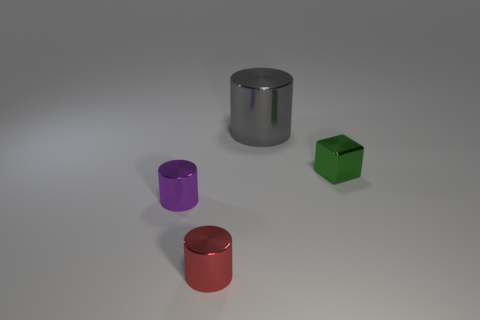The tiny cube that is the same material as the purple object is what color?
Offer a very short reply. Green. What number of objects are either large green balls or small green blocks?
Offer a terse response. 1. The green metallic object that is the same size as the red metallic object is what shape?
Make the answer very short. Cube. What number of cylinders are both in front of the purple object and behind the small shiny block?
Offer a terse response. 0. What is the cylinder that is in front of the purple cylinder made of?
Your answer should be very brief. Metal. There is a gray cylinder that is made of the same material as the tiny block; what size is it?
Offer a terse response. Large. Is the size of the object to the left of the red cylinder the same as the shiny cylinder in front of the tiny purple metal thing?
Ensure brevity in your answer.  Yes. There is a green object that is the same size as the purple metal cylinder; what is it made of?
Make the answer very short. Metal. The object that is behind the tiny purple object and to the left of the tiny green cube is made of what material?
Provide a succinct answer. Metal. Are any purple metallic spheres visible?
Your response must be concise. No. 